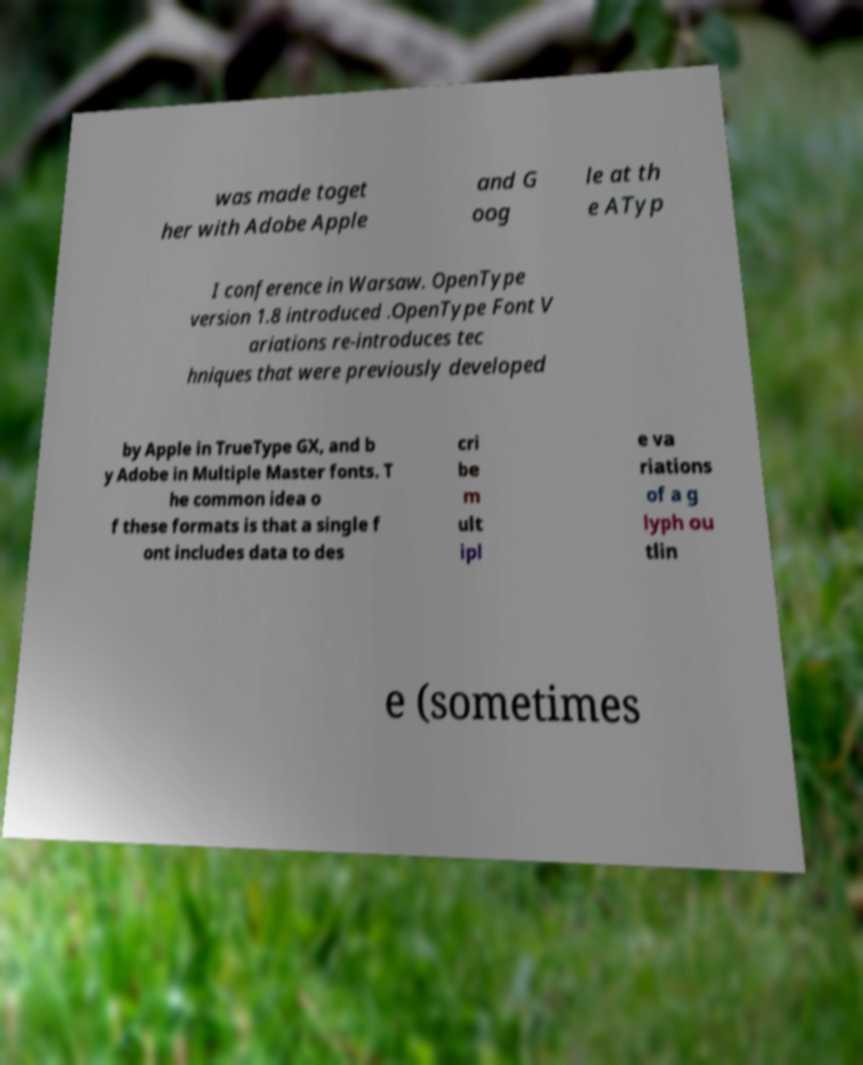For documentation purposes, I need the text within this image transcribed. Could you provide that? was made toget her with Adobe Apple and G oog le at th e ATyp I conference in Warsaw. OpenType version 1.8 introduced .OpenType Font V ariations re-introduces tec hniques that were previously developed by Apple in TrueType GX, and b y Adobe in Multiple Master fonts. T he common idea o f these formats is that a single f ont includes data to des cri be m ult ipl e va riations of a g lyph ou tlin e (sometimes 